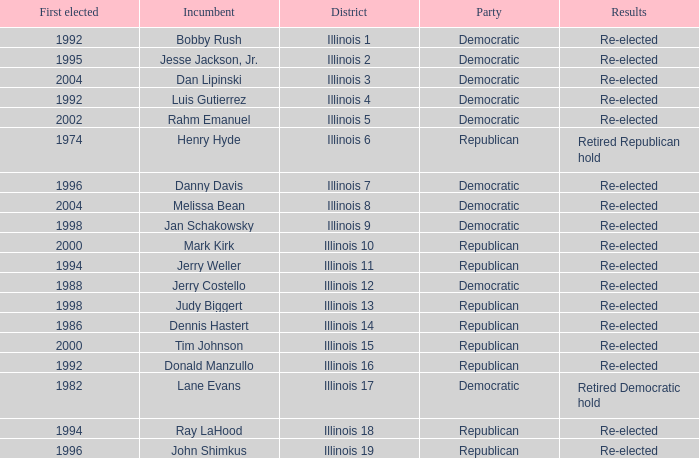What is Illinois 13 District's Party? Republican. 